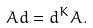<formula> <loc_0><loc_0><loc_500><loc_500>A d = d ^ { K } A .</formula> 